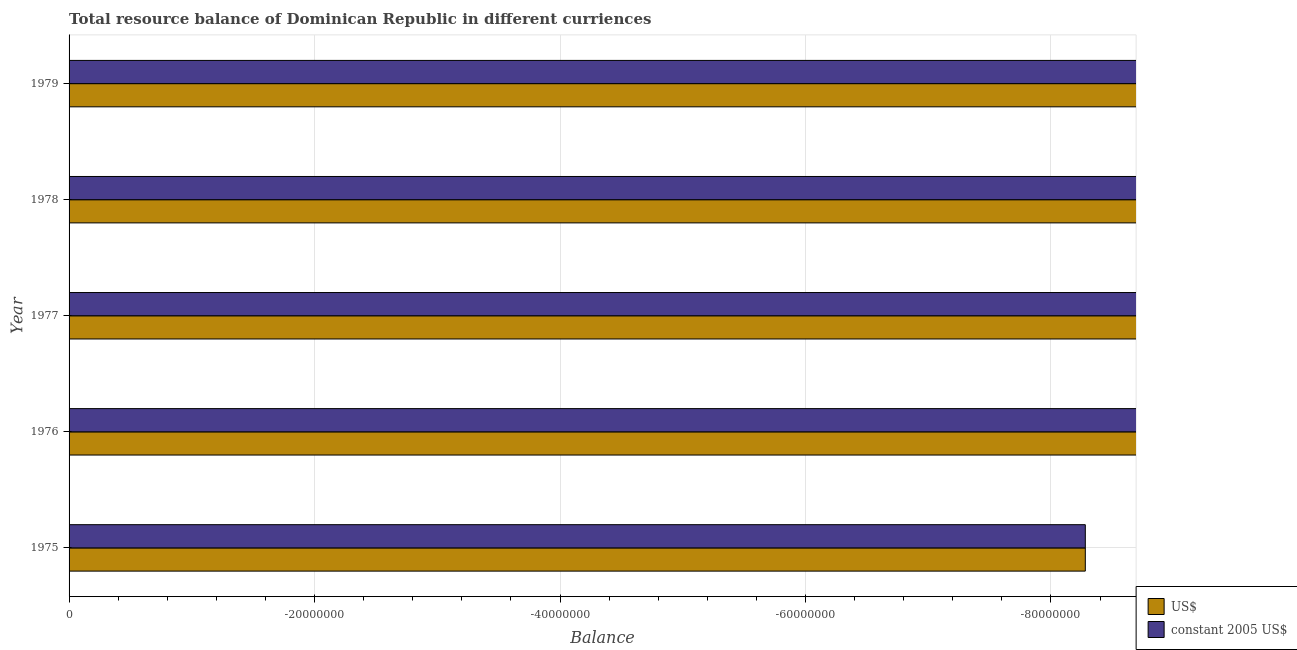How many different coloured bars are there?
Offer a terse response. 0. Are the number of bars per tick equal to the number of legend labels?
Offer a terse response. No. How many bars are there on the 4th tick from the top?
Provide a succinct answer. 0. How many bars are there on the 1st tick from the bottom?
Ensure brevity in your answer.  0. What is the label of the 4th group of bars from the top?
Your answer should be very brief. 1976. In how many cases, is the number of bars for a given year not equal to the number of legend labels?
Give a very brief answer. 5. What is the resource balance in constant us$ in 1977?
Offer a very short reply. 0. Across all years, what is the minimum resource balance in constant us$?
Keep it short and to the point. 0. What is the difference between the resource balance in us$ in 1975 and the resource balance in constant us$ in 1976?
Give a very brief answer. 0. Are the values on the major ticks of X-axis written in scientific E-notation?
Your answer should be compact. No. Where does the legend appear in the graph?
Offer a very short reply. Bottom right. How many legend labels are there?
Offer a very short reply. 2. What is the title of the graph?
Give a very brief answer. Total resource balance of Dominican Republic in different curriences. Does "Urban agglomerations" appear as one of the legend labels in the graph?
Provide a short and direct response. No. What is the label or title of the X-axis?
Ensure brevity in your answer.  Balance. What is the label or title of the Y-axis?
Provide a short and direct response. Year. What is the Balance in US$ in 1975?
Offer a terse response. 0. What is the Balance of US$ in 1976?
Offer a terse response. 0. What is the Balance of constant 2005 US$ in 1976?
Keep it short and to the point. 0. What is the Balance of US$ in 1977?
Offer a very short reply. 0. What is the Balance in constant 2005 US$ in 1977?
Ensure brevity in your answer.  0. What is the Balance of US$ in 1978?
Your answer should be very brief. 0. What is the Balance in constant 2005 US$ in 1978?
Provide a short and direct response. 0. What is the average Balance of US$ per year?
Make the answer very short. 0. 